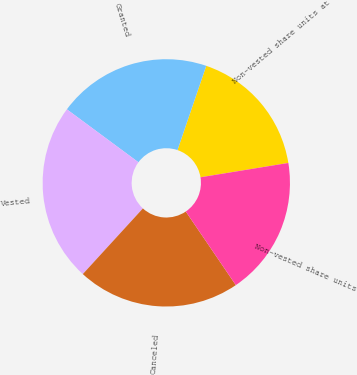<chart> <loc_0><loc_0><loc_500><loc_500><pie_chart><fcel>Non-vested share units at<fcel>Granted<fcel>Vested<fcel>Canceled<fcel>Non-vested share units<nl><fcel>17.19%<fcel>20.1%<fcel>23.34%<fcel>21.3%<fcel>18.07%<nl></chart> 